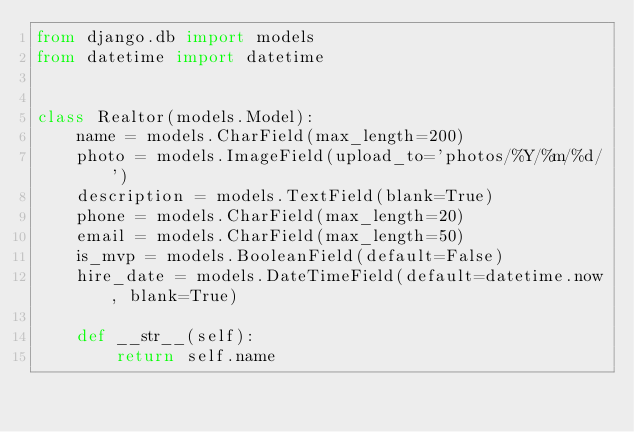<code> <loc_0><loc_0><loc_500><loc_500><_Python_>from django.db import models
from datetime import datetime


class Realtor(models.Model):
    name = models.CharField(max_length=200)
    photo = models.ImageField(upload_to='photos/%Y/%m/%d/')
    description = models.TextField(blank=True)
    phone = models.CharField(max_length=20)
    email = models.CharField(max_length=50)
    is_mvp = models.BooleanField(default=False)
    hire_date = models.DateTimeField(default=datetime.now, blank=True)

    def __str__(self):
        return self.name
</code> 